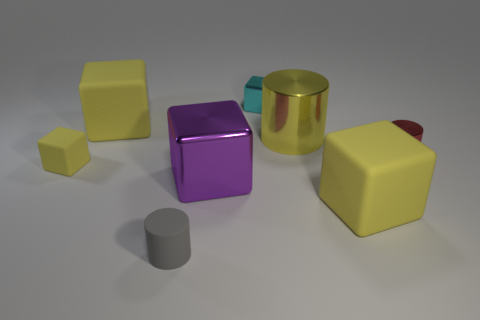Subtract all purple cylinders. How many yellow blocks are left? 3 Subtract all tiny cyan metallic blocks. How many blocks are left? 4 Subtract all cyan cubes. How many cubes are left? 4 Subtract 2 cubes. How many cubes are left? 3 Subtract all red cubes. Subtract all brown cylinders. How many cubes are left? 5 Add 1 purple things. How many objects exist? 9 Subtract all cylinders. How many objects are left? 5 Add 5 big cubes. How many big cubes exist? 8 Subtract 1 gray cylinders. How many objects are left? 7 Subtract all big purple matte objects. Subtract all tiny red shiny things. How many objects are left? 7 